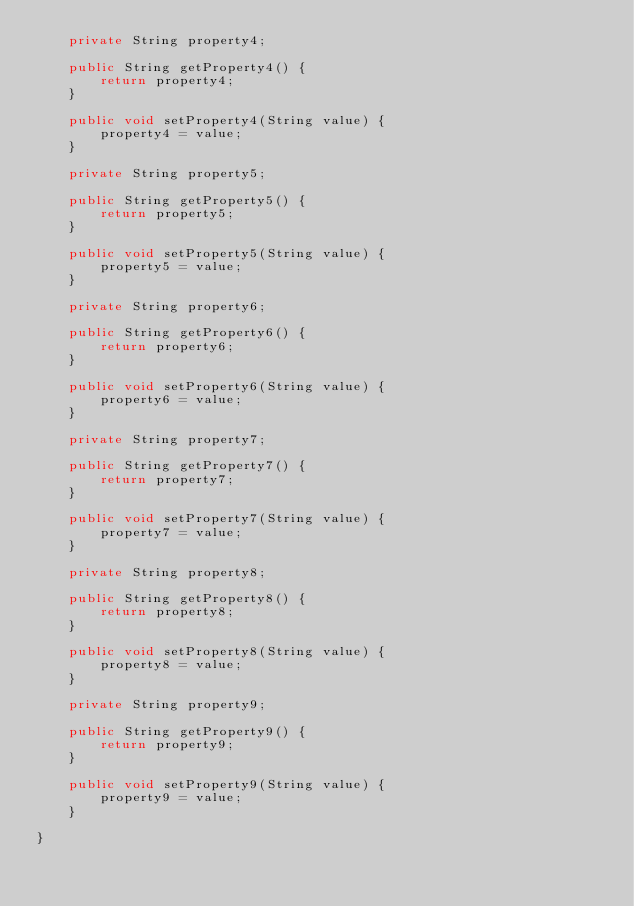<code> <loc_0><loc_0><loc_500><loc_500><_Java_>    private String property4;

    public String getProperty4() {
        return property4;
    }

    public void setProperty4(String value) {
        property4 = value;
    }

    private String property5;

    public String getProperty5() {
        return property5;
    }

    public void setProperty5(String value) {
        property5 = value;
    }

    private String property6;

    public String getProperty6() {
        return property6;
    }

    public void setProperty6(String value) {
        property6 = value;
    }

    private String property7;

    public String getProperty7() {
        return property7;
    }

    public void setProperty7(String value) {
        property7 = value;
    }

    private String property8;

    public String getProperty8() {
        return property8;
    }

    public void setProperty8(String value) {
        property8 = value;
    }

    private String property9;

    public String getProperty9() {
        return property9;
    }

    public void setProperty9(String value) {
        property9 = value;
    }

}</code> 